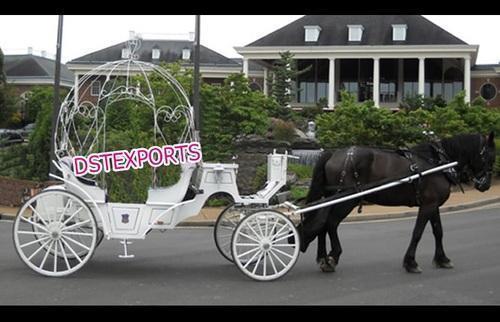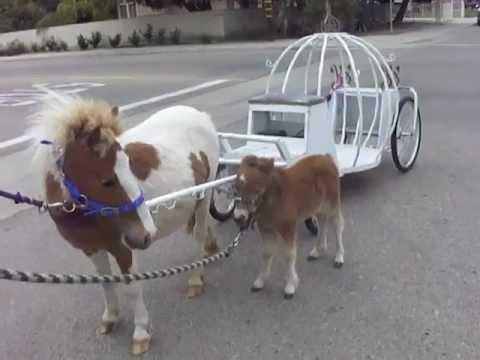The first image is the image on the left, the second image is the image on the right. Assess this claim about the two images: "there are white horses with tassels on the top of their heads pulling a cinderella type princess carriage". Correct or not? Answer yes or no. No. The first image is the image on the left, the second image is the image on the right. For the images shown, is this caption "In at least one image there are two white horses pulling a white pumpkin carriage." true? Answer yes or no. No. 